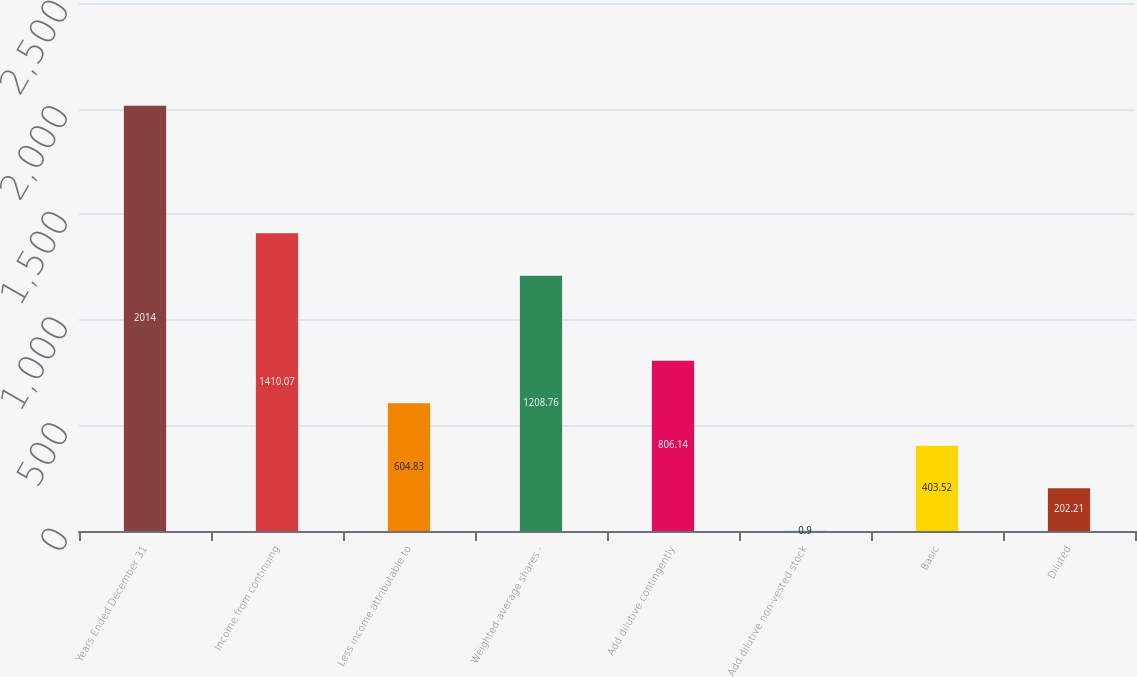Convert chart. <chart><loc_0><loc_0><loc_500><loc_500><bar_chart><fcel>Years Ended December 31<fcel>Income from continuing<fcel>Less income attributable to<fcel>Weighted-average shares -<fcel>Add dilutive contingently<fcel>Add dilutive non-vested stock<fcel>Basic<fcel>Diluted<nl><fcel>2014<fcel>1410.07<fcel>604.83<fcel>1208.76<fcel>806.14<fcel>0.9<fcel>403.52<fcel>202.21<nl></chart> 